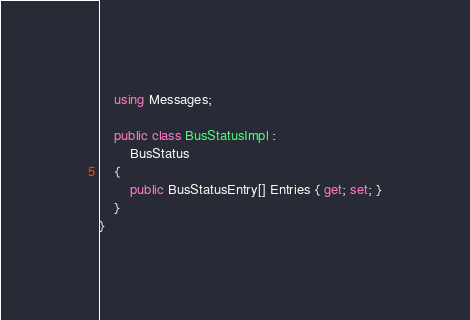Convert code to text. <code><loc_0><loc_0><loc_500><loc_500><_C#_>    using Messages;

    public class BusStatusImpl :
        BusStatus
    {
        public BusStatusEntry[] Entries { get; set; }
    }
}</code> 